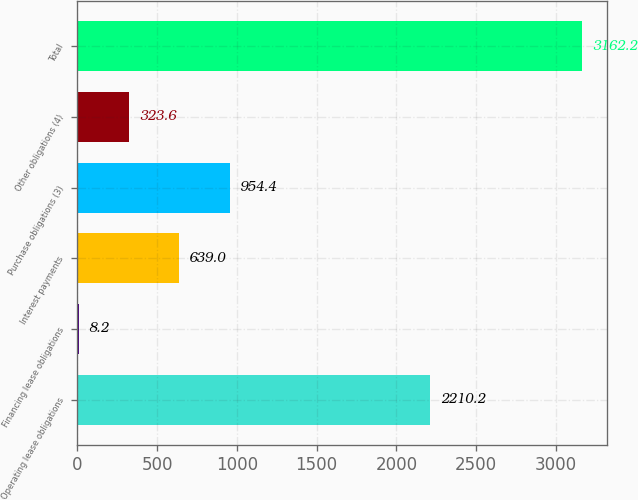<chart> <loc_0><loc_0><loc_500><loc_500><bar_chart><fcel>Operating lease obligations<fcel>Financing lease obligations<fcel>Interest payments<fcel>Purchase obligations (3)<fcel>Other obligations (4)<fcel>Total<nl><fcel>2210.2<fcel>8.2<fcel>639<fcel>954.4<fcel>323.6<fcel>3162.2<nl></chart> 